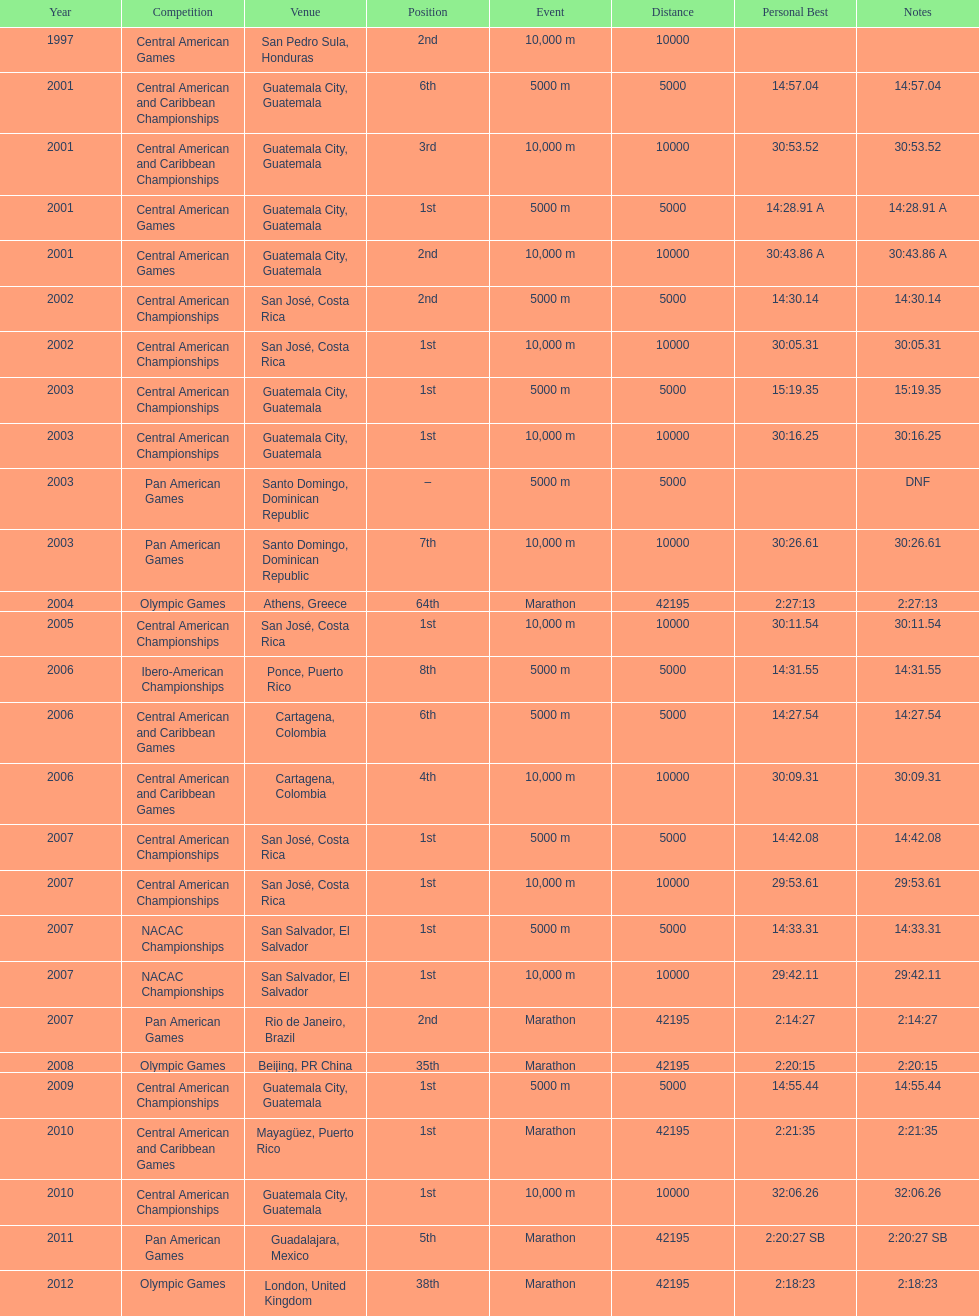What was the first competition this competitor competed in? Central American Games. 